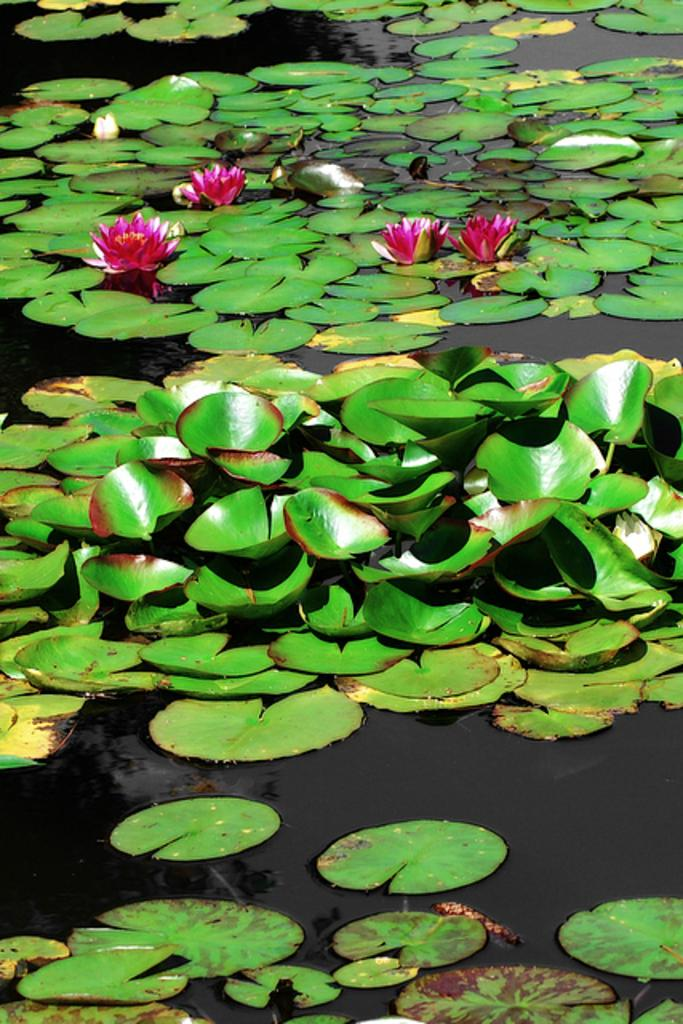What type of plants can be seen in the image? There are flowers and leaves in the image. Where are the flowers and leaves located? The flowers and leaves are on the water. How many brothers are depicted in the image? There are no brothers present in the image; it features flowers and leaves on the water. What type of rain is visible in the image? There is no rain present in the image; it features flowers and leaves on the water. 